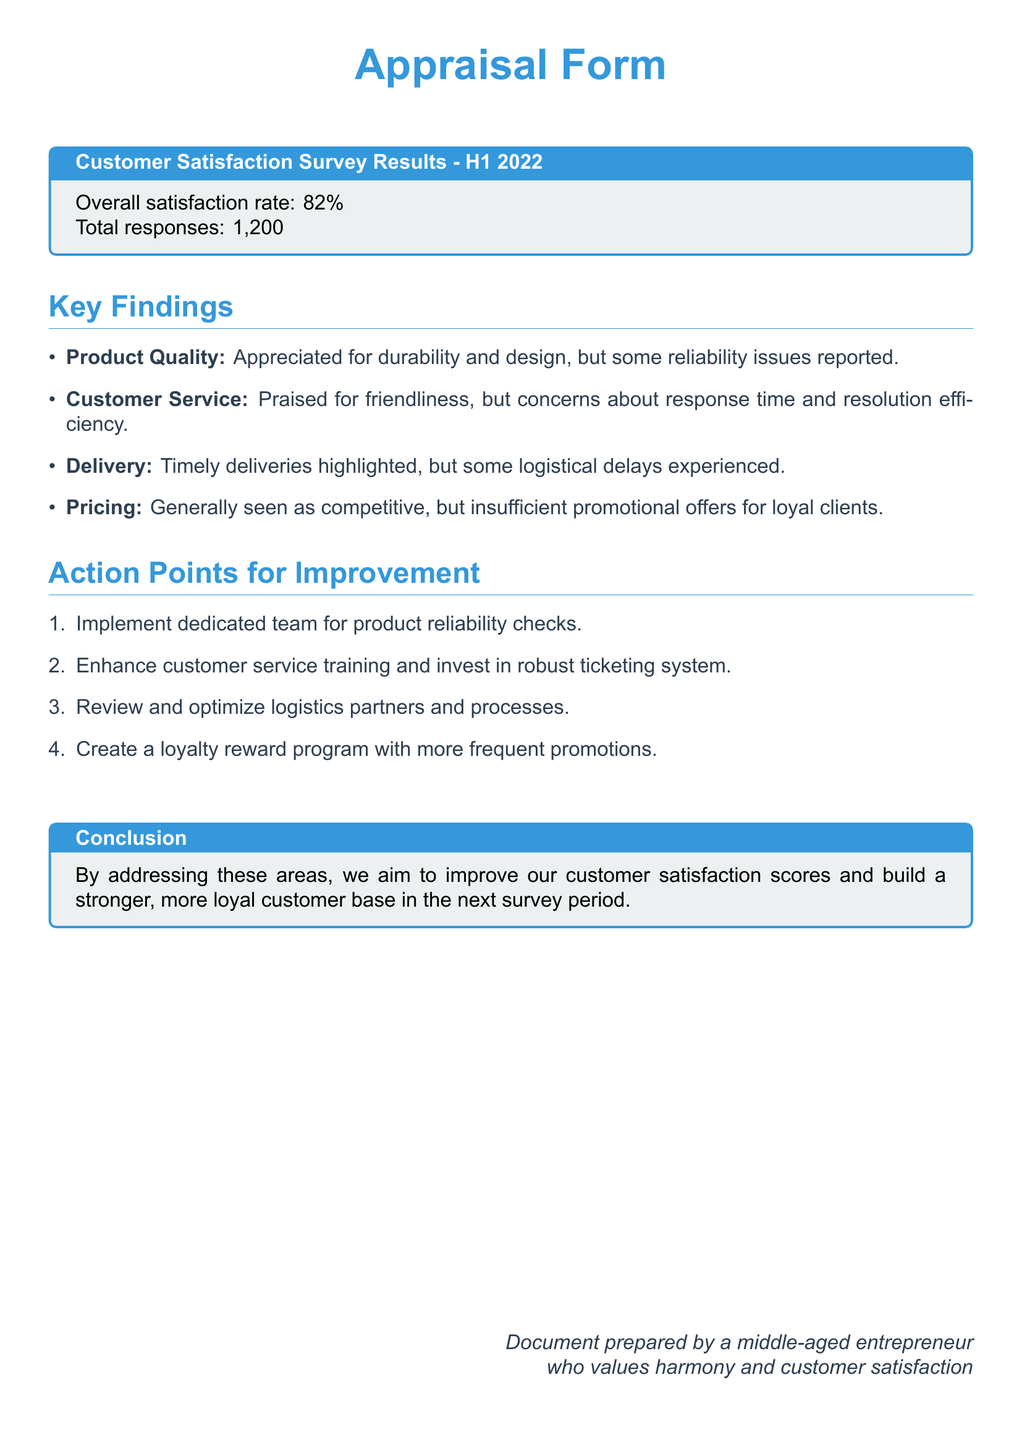What is the overall satisfaction rate? The overall satisfaction rate is specified in the document as a percentage of customer satisfaction.
Answer: 82% How many responses were collected? The total number of responses is stated in the document, indicating participation in the survey.
Answer: 1,200 What aspect of customer service received praise? The document mentions a specific quality that customers appreciated about the service provided.
Answer: Friendliness What issue was reported regarding product reliability? The document highlights a concern that customers expressed about product performance.
Answer: Reliability issues What is one proposed action point regarding logistics? The document includes an action point related to improving logistical processes based on customer feedback.
Answer: Optimize logistics partners What was generally seen as competitive? The document indicates an aspect of the offering that customers found favorable in comparison to competitors.
Answer: Pricing What theme was highlighted regarding deliveries? The document specifies a particular strength related to delivery performance that was acknowledged by customers.
Answer: Timely deliveries Which training is suggested for customer service improvement? The document outlines a specific focus area for enhancing customer service quality through training initiatives.
Answer: Customer service training What should be created to reward loyal clients? The document proposes a specific program aimed at fostering loyalty among returning customers.
Answer: Loyalty reward program 